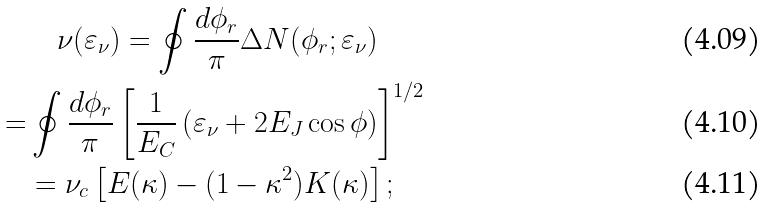<formula> <loc_0><loc_0><loc_500><loc_500>& \quad \nu ( \varepsilon _ { \nu } ) = \oint \frac { d \phi _ { r } } { \pi } \Delta N ( \phi _ { r } ; \varepsilon _ { \nu } ) \\ = & \oint \frac { d \phi _ { r } } { \pi } \left [ \frac { 1 } { E _ { C } } \left ( \varepsilon _ { \nu } + 2 E _ { J } \cos \phi \right ) \right ] ^ { 1 / 2 } \\ & = \nu _ { c } \left [ E ( \kappa ) - ( 1 - \kappa ^ { 2 } ) K ( \kappa ) \right ] ;</formula> 